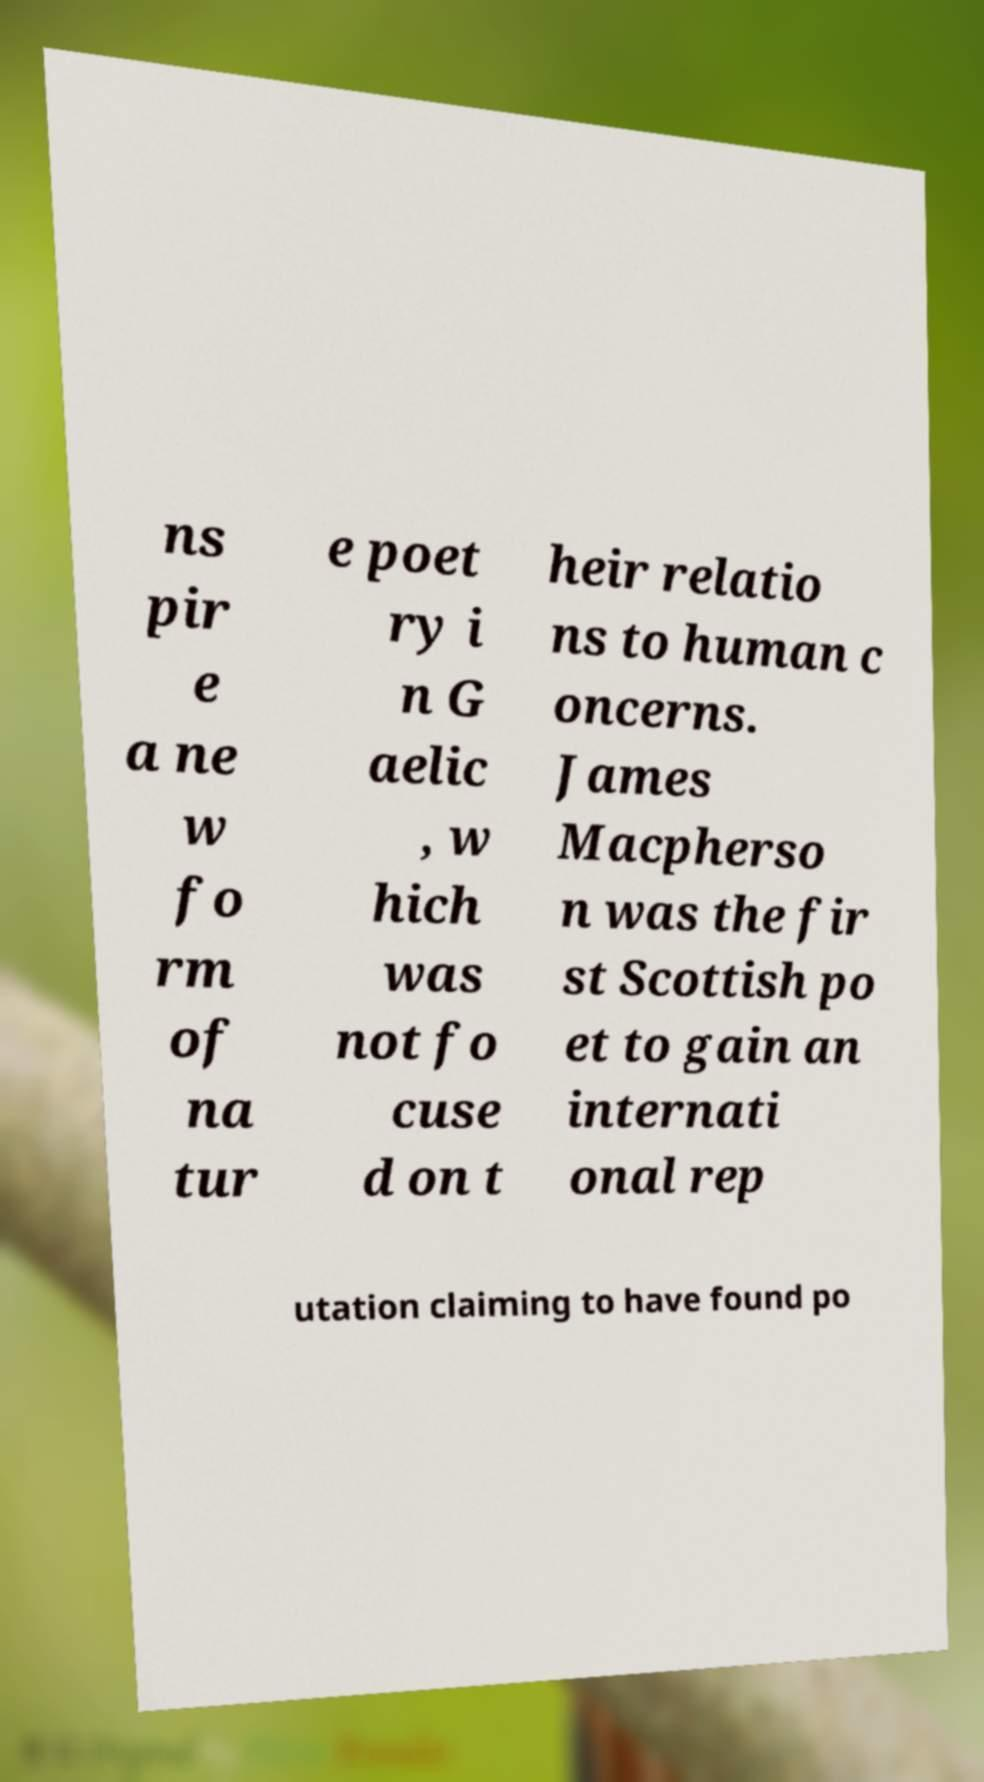Could you extract and type out the text from this image? ns pir e a ne w fo rm of na tur e poet ry i n G aelic , w hich was not fo cuse d on t heir relatio ns to human c oncerns. James Macpherso n was the fir st Scottish po et to gain an internati onal rep utation claiming to have found po 